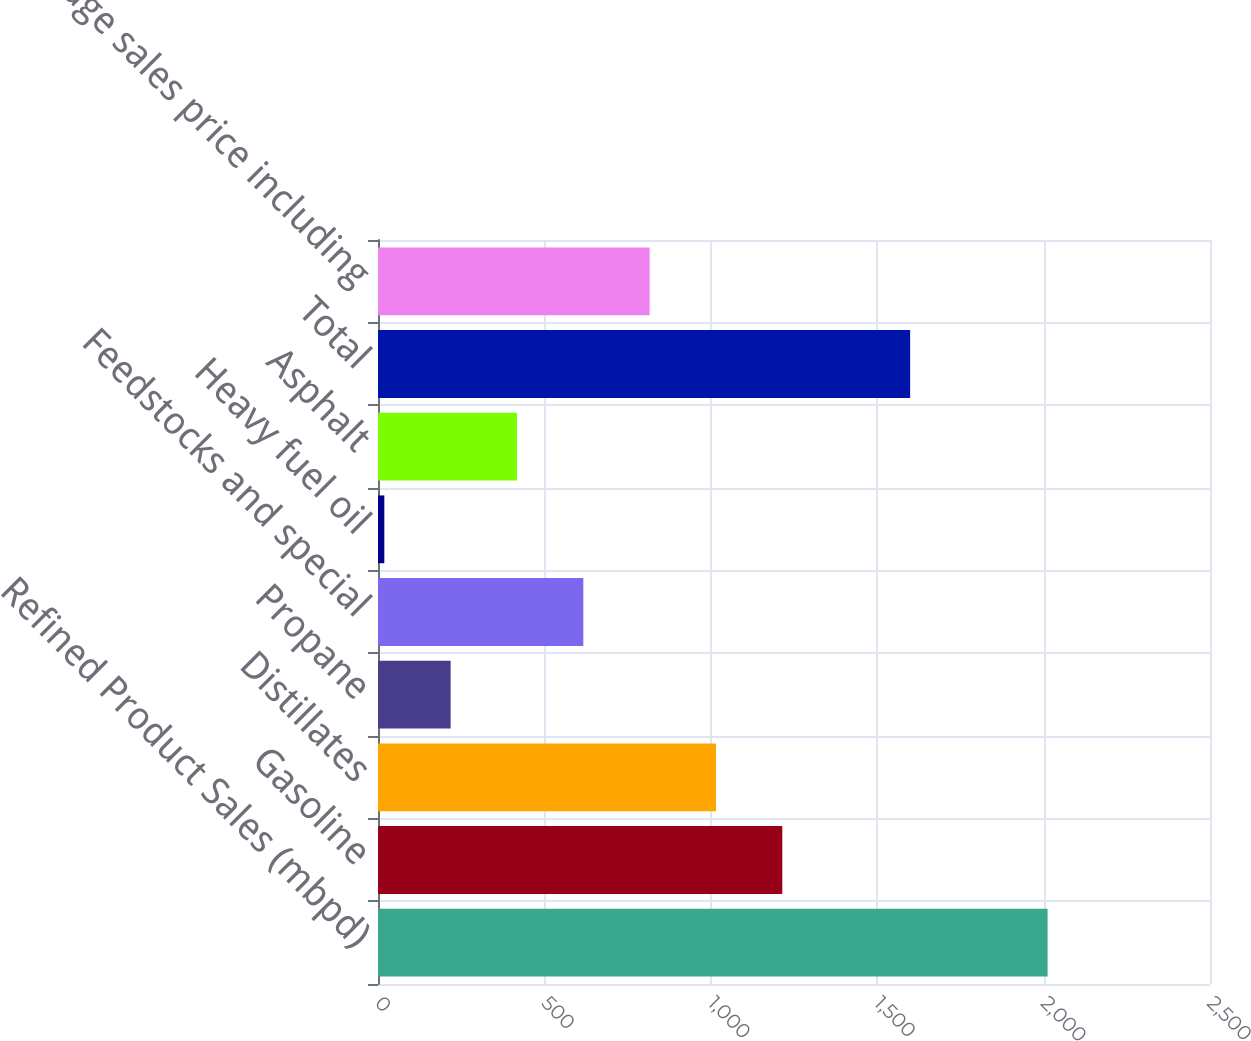Convert chart to OTSL. <chart><loc_0><loc_0><loc_500><loc_500><bar_chart><fcel>Refined Product Sales (mbpd)<fcel>Gasoline<fcel>Distillates<fcel>Propane<fcel>Feedstocks and special<fcel>Heavy fuel oil<fcel>Asphalt<fcel>Total<fcel>Average sales price including<nl><fcel>2012<fcel>1214.8<fcel>1015.5<fcel>218.3<fcel>616.9<fcel>19<fcel>417.6<fcel>1599<fcel>816.2<nl></chart> 